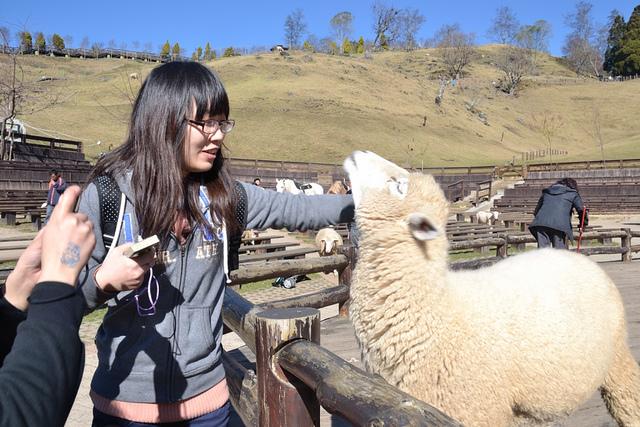Does the woman own this sheep?
Quick response, please. No. What is the sheep enclosed in?
Quick response, please. Fence. Did the llama fall asleep while standing?
Give a very brief answer. No. 